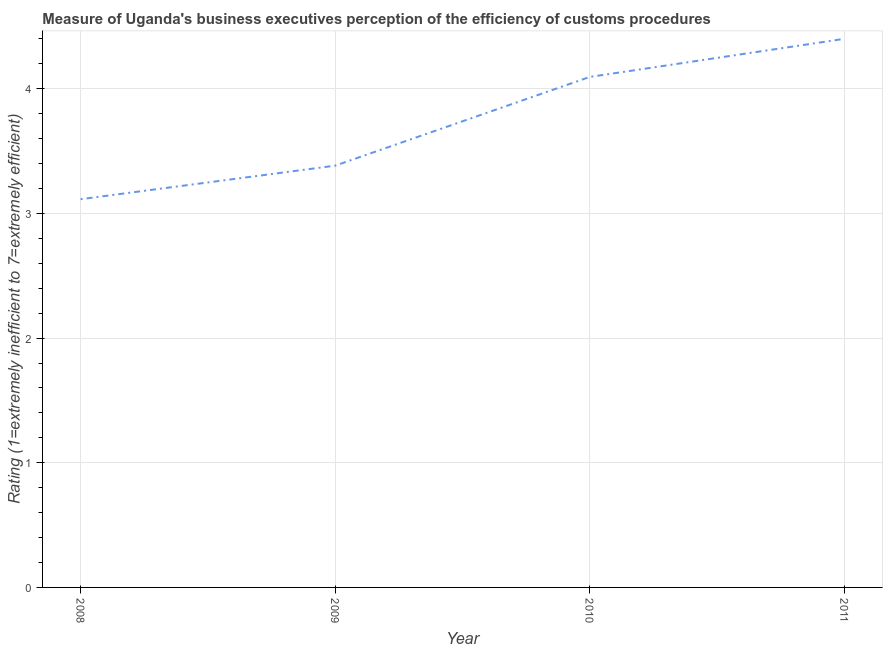What is the rating measuring burden of customs procedure in 2009?
Keep it short and to the point. 3.38. Across all years, what is the maximum rating measuring burden of customs procedure?
Give a very brief answer. 4.4. Across all years, what is the minimum rating measuring burden of customs procedure?
Provide a short and direct response. 3.11. What is the sum of the rating measuring burden of customs procedure?
Give a very brief answer. 14.99. What is the difference between the rating measuring burden of customs procedure in 2008 and 2009?
Offer a terse response. -0.27. What is the average rating measuring burden of customs procedure per year?
Provide a short and direct response. 3.75. What is the median rating measuring burden of customs procedure?
Keep it short and to the point. 3.74. What is the ratio of the rating measuring burden of customs procedure in 2008 to that in 2011?
Make the answer very short. 0.71. Is the difference between the rating measuring burden of customs procedure in 2008 and 2010 greater than the difference between any two years?
Your response must be concise. No. What is the difference between the highest and the second highest rating measuring burden of customs procedure?
Your answer should be compact. 0.31. What is the difference between the highest and the lowest rating measuring burden of customs procedure?
Provide a short and direct response. 1.29. In how many years, is the rating measuring burden of customs procedure greater than the average rating measuring burden of customs procedure taken over all years?
Keep it short and to the point. 2. How many years are there in the graph?
Ensure brevity in your answer.  4. What is the difference between two consecutive major ticks on the Y-axis?
Give a very brief answer. 1. Does the graph contain any zero values?
Your response must be concise. No. Does the graph contain grids?
Give a very brief answer. Yes. What is the title of the graph?
Provide a succinct answer. Measure of Uganda's business executives perception of the efficiency of customs procedures. What is the label or title of the X-axis?
Your answer should be very brief. Year. What is the label or title of the Y-axis?
Your response must be concise. Rating (1=extremely inefficient to 7=extremely efficient). What is the Rating (1=extremely inefficient to 7=extremely efficient) of 2008?
Your answer should be compact. 3.11. What is the Rating (1=extremely inefficient to 7=extremely efficient) of 2009?
Offer a very short reply. 3.38. What is the Rating (1=extremely inefficient to 7=extremely efficient) in 2010?
Keep it short and to the point. 4.09. What is the difference between the Rating (1=extremely inefficient to 7=extremely efficient) in 2008 and 2009?
Your answer should be compact. -0.27. What is the difference between the Rating (1=extremely inefficient to 7=extremely efficient) in 2008 and 2010?
Offer a terse response. -0.98. What is the difference between the Rating (1=extremely inefficient to 7=extremely efficient) in 2008 and 2011?
Keep it short and to the point. -1.29. What is the difference between the Rating (1=extremely inefficient to 7=extremely efficient) in 2009 and 2010?
Ensure brevity in your answer.  -0.71. What is the difference between the Rating (1=extremely inefficient to 7=extremely efficient) in 2009 and 2011?
Provide a succinct answer. -1.02. What is the difference between the Rating (1=extremely inefficient to 7=extremely efficient) in 2010 and 2011?
Keep it short and to the point. -0.31. What is the ratio of the Rating (1=extremely inefficient to 7=extremely efficient) in 2008 to that in 2010?
Your answer should be compact. 0.76. What is the ratio of the Rating (1=extremely inefficient to 7=extremely efficient) in 2008 to that in 2011?
Give a very brief answer. 0.71. What is the ratio of the Rating (1=extremely inefficient to 7=extremely efficient) in 2009 to that in 2010?
Ensure brevity in your answer.  0.83. What is the ratio of the Rating (1=extremely inefficient to 7=extremely efficient) in 2009 to that in 2011?
Make the answer very short. 0.77. What is the ratio of the Rating (1=extremely inefficient to 7=extremely efficient) in 2010 to that in 2011?
Your response must be concise. 0.93. 